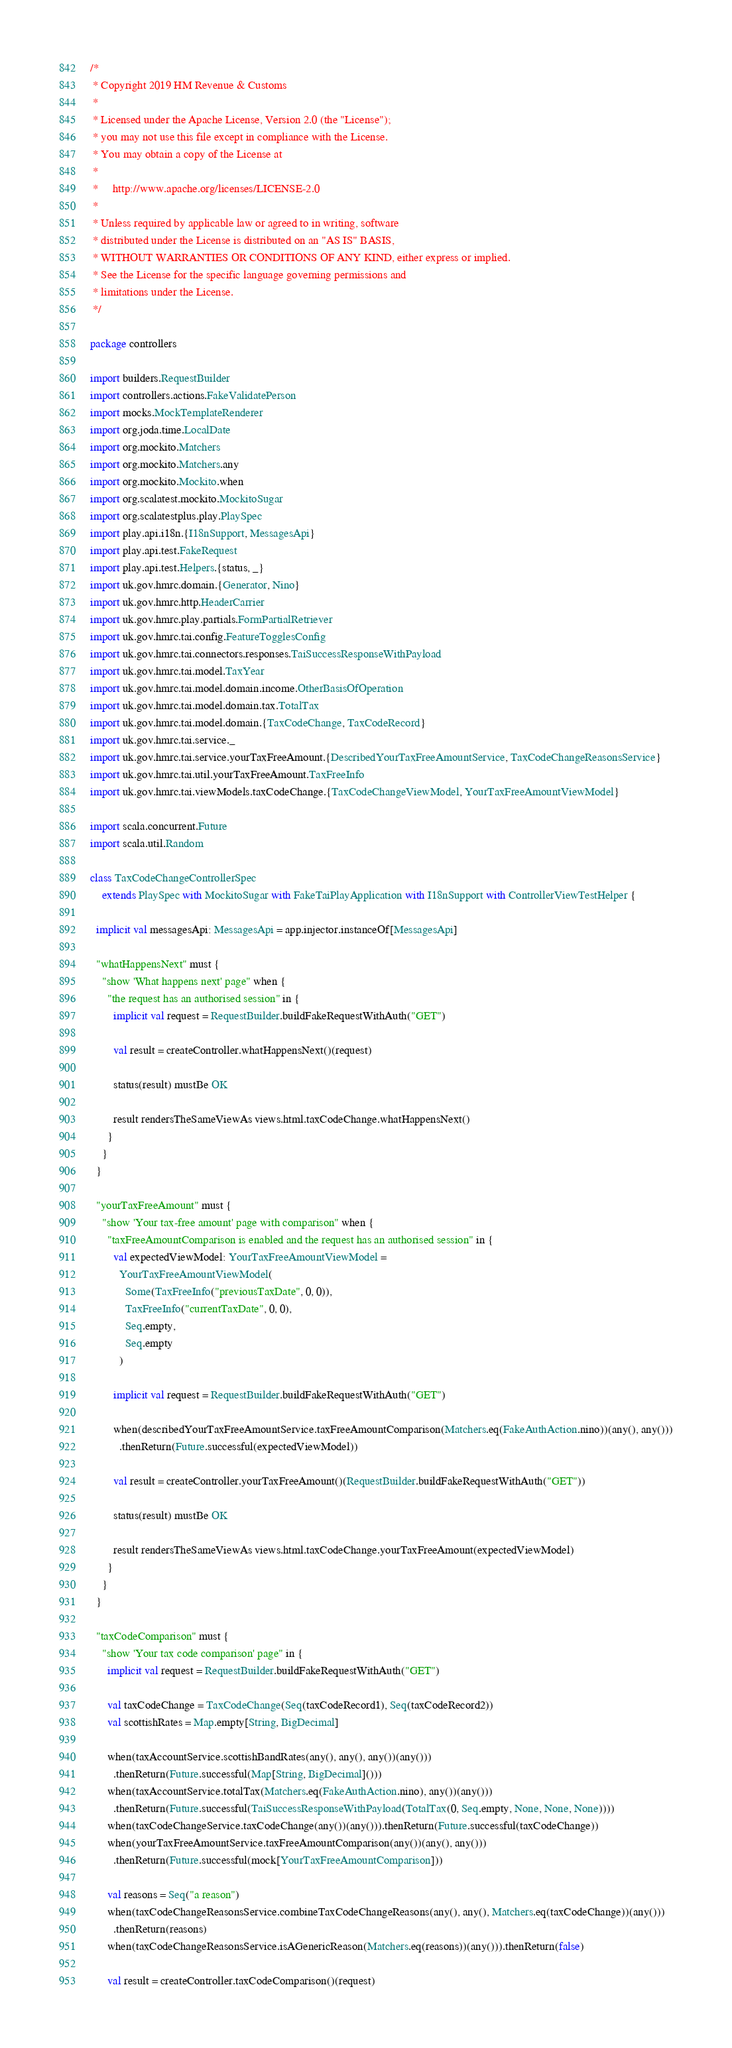Convert code to text. <code><loc_0><loc_0><loc_500><loc_500><_Scala_>/*
 * Copyright 2019 HM Revenue & Customs
 *
 * Licensed under the Apache License, Version 2.0 (the "License");
 * you may not use this file except in compliance with the License.
 * You may obtain a copy of the License at
 *
 *     http://www.apache.org/licenses/LICENSE-2.0
 *
 * Unless required by applicable law or agreed to in writing, software
 * distributed under the License is distributed on an "AS IS" BASIS,
 * WITHOUT WARRANTIES OR CONDITIONS OF ANY KIND, either express or implied.
 * See the License for the specific language governing permissions and
 * limitations under the License.
 */

package controllers

import builders.RequestBuilder
import controllers.actions.FakeValidatePerson
import mocks.MockTemplateRenderer
import org.joda.time.LocalDate
import org.mockito.Matchers
import org.mockito.Matchers.any
import org.mockito.Mockito.when
import org.scalatest.mockito.MockitoSugar
import org.scalatestplus.play.PlaySpec
import play.api.i18n.{I18nSupport, MessagesApi}
import play.api.test.FakeRequest
import play.api.test.Helpers.{status, _}
import uk.gov.hmrc.domain.{Generator, Nino}
import uk.gov.hmrc.http.HeaderCarrier
import uk.gov.hmrc.play.partials.FormPartialRetriever
import uk.gov.hmrc.tai.config.FeatureTogglesConfig
import uk.gov.hmrc.tai.connectors.responses.TaiSuccessResponseWithPayload
import uk.gov.hmrc.tai.model.TaxYear
import uk.gov.hmrc.tai.model.domain.income.OtherBasisOfOperation
import uk.gov.hmrc.tai.model.domain.tax.TotalTax
import uk.gov.hmrc.tai.model.domain.{TaxCodeChange, TaxCodeRecord}
import uk.gov.hmrc.tai.service._
import uk.gov.hmrc.tai.service.yourTaxFreeAmount.{DescribedYourTaxFreeAmountService, TaxCodeChangeReasonsService}
import uk.gov.hmrc.tai.util.yourTaxFreeAmount.TaxFreeInfo
import uk.gov.hmrc.tai.viewModels.taxCodeChange.{TaxCodeChangeViewModel, YourTaxFreeAmountViewModel}

import scala.concurrent.Future
import scala.util.Random

class TaxCodeChangeControllerSpec
    extends PlaySpec with MockitoSugar with FakeTaiPlayApplication with I18nSupport with ControllerViewTestHelper {

  implicit val messagesApi: MessagesApi = app.injector.instanceOf[MessagesApi]

  "whatHappensNext" must {
    "show 'What happens next' page" when {
      "the request has an authorised session" in {
        implicit val request = RequestBuilder.buildFakeRequestWithAuth("GET")

        val result = createController.whatHappensNext()(request)

        status(result) mustBe OK

        result rendersTheSameViewAs views.html.taxCodeChange.whatHappensNext()
      }
    }
  }

  "yourTaxFreeAmount" must {
    "show 'Your tax-free amount' page with comparison" when {
      "taxFreeAmountComparison is enabled and the request has an authorised session" in {
        val expectedViewModel: YourTaxFreeAmountViewModel =
          YourTaxFreeAmountViewModel(
            Some(TaxFreeInfo("previousTaxDate", 0, 0)),
            TaxFreeInfo("currentTaxDate", 0, 0),
            Seq.empty,
            Seq.empty
          )

        implicit val request = RequestBuilder.buildFakeRequestWithAuth("GET")

        when(describedYourTaxFreeAmountService.taxFreeAmountComparison(Matchers.eq(FakeAuthAction.nino))(any(), any()))
          .thenReturn(Future.successful(expectedViewModel))

        val result = createController.yourTaxFreeAmount()(RequestBuilder.buildFakeRequestWithAuth("GET"))

        status(result) mustBe OK

        result rendersTheSameViewAs views.html.taxCodeChange.yourTaxFreeAmount(expectedViewModel)
      }
    }
  }

  "taxCodeComparison" must {
    "show 'Your tax code comparison' page" in {
      implicit val request = RequestBuilder.buildFakeRequestWithAuth("GET")

      val taxCodeChange = TaxCodeChange(Seq(taxCodeRecord1), Seq(taxCodeRecord2))
      val scottishRates = Map.empty[String, BigDecimal]

      when(taxAccountService.scottishBandRates(any(), any(), any())(any()))
        .thenReturn(Future.successful(Map[String, BigDecimal]()))
      when(taxAccountService.totalTax(Matchers.eq(FakeAuthAction.nino), any())(any()))
        .thenReturn(Future.successful(TaiSuccessResponseWithPayload(TotalTax(0, Seq.empty, None, None, None))))
      when(taxCodeChangeService.taxCodeChange(any())(any())).thenReturn(Future.successful(taxCodeChange))
      when(yourTaxFreeAmountService.taxFreeAmountComparison(any())(any(), any()))
        .thenReturn(Future.successful(mock[YourTaxFreeAmountComparison]))

      val reasons = Seq("a reason")
      when(taxCodeChangeReasonsService.combineTaxCodeChangeReasons(any(), any(), Matchers.eq(taxCodeChange))(any()))
        .thenReturn(reasons)
      when(taxCodeChangeReasonsService.isAGenericReason(Matchers.eq(reasons))(any())).thenReturn(false)

      val result = createController.taxCodeComparison()(request)
</code> 